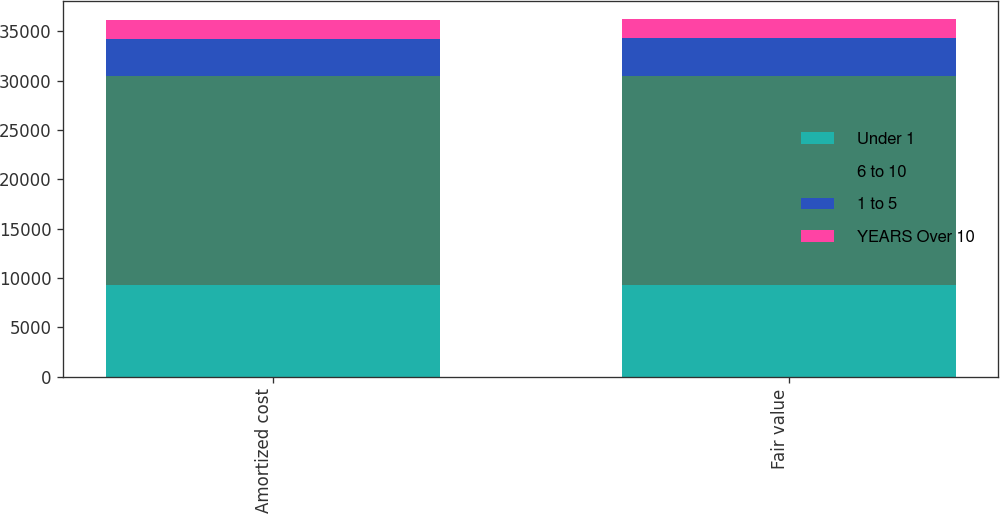Convert chart to OTSL. <chart><loc_0><loc_0><loc_500><loc_500><stacked_bar_chart><ecel><fcel>Amortized cost<fcel>Fair value<nl><fcel>Under 1<fcel>9299<fcel>9309<nl><fcel>6 to 10<fcel>21140<fcel>21216<nl><fcel>1 to 5<fcel>3837<fcel>3853<nl><fcel>YEARS Over 10<fcel>1874<fcel>1897<nl></chart> 